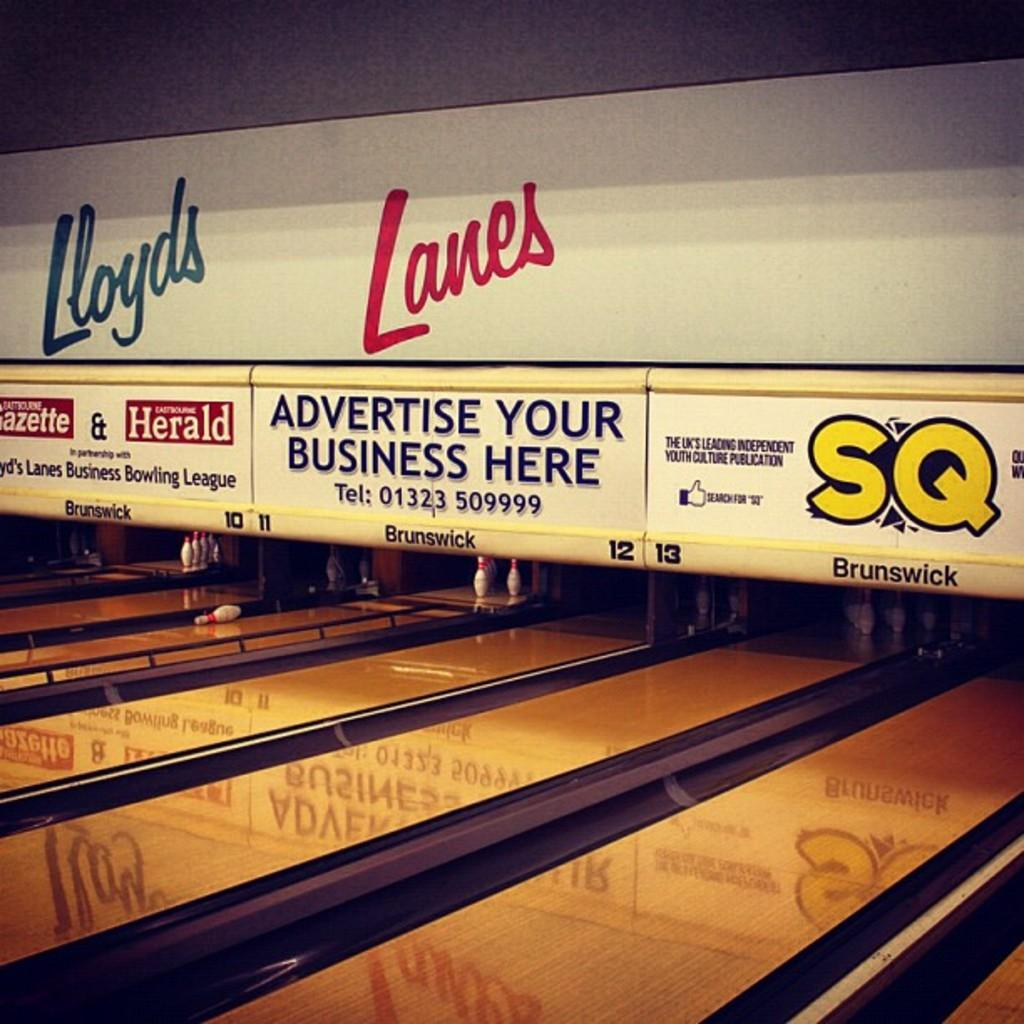What type of activity is taking place in the image? There are bowling alleys in the image, which suggests that the activity is bowling. What objects can be seen in the image besides the bowling alleys? There are boards and writing on the wall visible in the image. What type of disease is mentioned in the writing on the wall in the image? There is no mention of any disease in the writing on the wall in the image. 